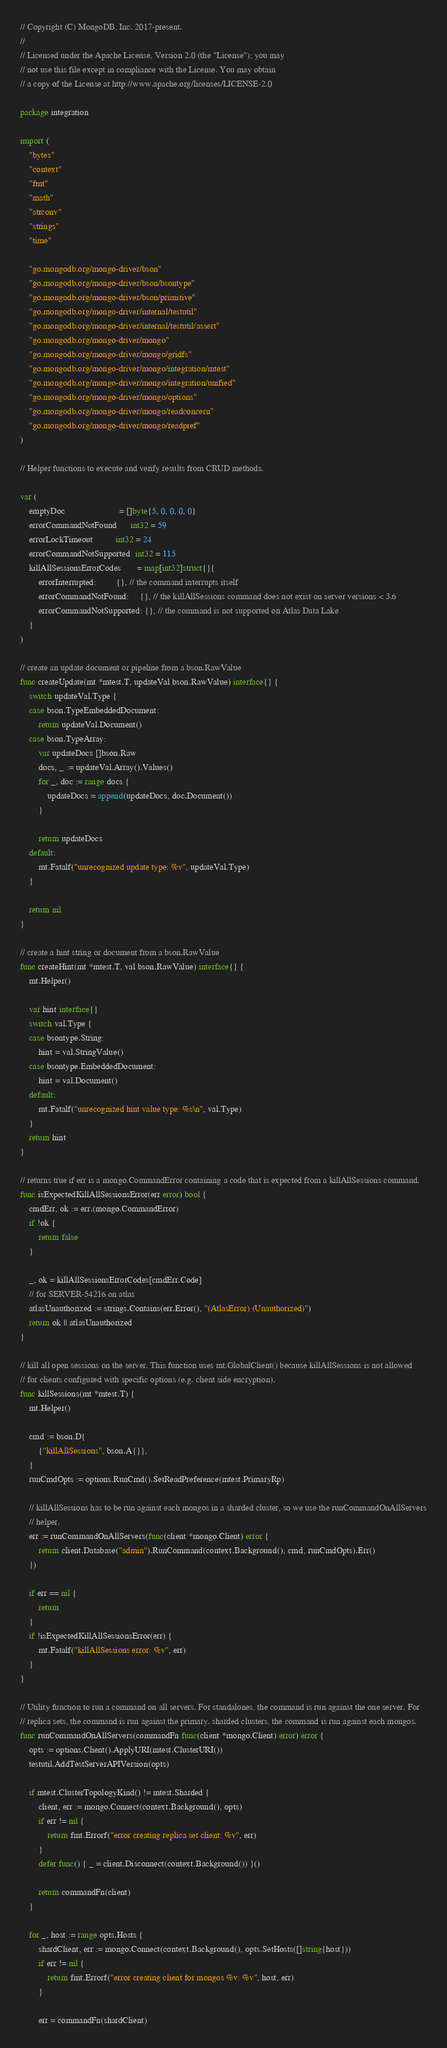<code> <loc_0><loc_0><loc_500><loc_500><_Go_>// Copyright (C) MongoDB, Inc. 2017-present.
//
// Licensed under the Apache License, Version 2.0 (the "License"); you may
// not use this file except in compliance with the License. You may obtain
// a copy of the License at http://www.apache.org/licenses/LICENSE-2.0

package integration

import (
	"bytes"
	"context"
	"fmt"
	"math"
	"strconv"
	"strings"
	"time"

	"go.mongodb.org/mongo-driver/bson"
	"go.mongodb.org/mongo-driver/bson/bsontype"
	"go.mongodb.org/mongo-driver/bson/primitive"
	"go.mongodb.org/mongo-driver/internal/testutil"
	"go.mongodb.org/mongo-driver/internal/testutil/assert"
	"go.mongodb.org/mongo-driver/mongo"
	"go.mongodb.org/mongo-driver/mongo/gridfs"
	"go.mongodb.org/mongo-driver/mongo/integration/mtest"
	"go.mongodb.org/mongo-driver/mongo/integration/unified"
	"go.mongodb.org/mongo-driver/mongo/options"
	"go.mongodb.org/mongo-driver/mongo/readconcern"
	"go.mongodb.org/mongo-driver/mongo/readpref"
)

// Helper functions to execute and verify results from CRUD methods.

var (
	emptyDoc                        = []byte{5, 0, 0, 0, 0}
	errorCommandNotFound      int32 = 59
	errorLockTimeout          int32 = 24
	errorCommandNotSupported  int32 = 115
	killAllSessionsErrorCodes       = map[int32]struct{}{
		errorInterrupted:         {}, // the command interrupts itself
		errorCommandNotFound:     {}, // the killAllSessions command does not exist on server versions < 3.6
		errorCommandNotSupported: {}, // the command is not supported on Atlas Data Lake
	}
)

// create an update document or pipeline from a bson.RawValue
func createUpdate(mt *mtest.T, updateVal bson.RawValue) interface{} {
	switch updateVal.Type {
	case bson.TypeEmbeddedDocument:
		return updateVal.Document()
	case bson.TypeArray:
		var updateDocs []bson.Raw
		docs, _ := updateVal.Array().Values()
		for _, doc := range docs {
			updateDocs = append(updateDocs, doc.Document())
		}

		return updateDocs
	default:
		mt.Fatalf("unrecognized update type: %v", updateVal.Type)
	}

	return nil
}

// create a hint string or document from a bson.RawValue
func createHint(mt *mtest.T, val bson.RawValue) interface{} {
	mt.Helper()

	var hint interface{}
	switch val.Type {
	case bsontype.String:
		hint = val.StringValue()
	case bsontype.EmbeddedDocument:
		hint = val.Document()
	default:
		mt.Fatalf("unrecognized hint value type: %s\n", val.Type)
	}
	return hint
}

// returns true if err is a mongo.CommandError containing a code that is expected from a killAllSessions command.
func isExpectedKillAllSessionsError(err error) bool {
	cmdErr, ok := err.(mongo.CommandError)
	if !ok {
		return false
	}

	_, ok = killAllSessionsErrorCodes[cmdErr.Code]
	// for SERVER-54216 on atlas
	atlasUnauthorized := strings.Contains(err.Error(), "(AtlasError) (Unauthorized)")
	return ok || atlasUnauthorized
}

// kill all open sessions on the server. This function uses mt.GlobalClient() because killAllSessions is not allowed
// for clients configured with specific options (e.g. client side encryption).
func killSessions(mt *mtest.T) {
	mt.Helper()

	cmd := bson.D{
		{"killAllSessions", bson.A{}},
	}
	runCmdOpts := options.RunCmd().SetReadPreference(mtest.PrimaryRp)

	// killAllSessions has to be run against each mongos in a sharded cluster, so we use the runCommandOnAllServers
	// helper.
	err := runCommandOnAllServers(func(client *mongo.Client) error {
		return client.Database("admin").RunCommand(context.Background(), cmd, runCmdOpts).Err()
	})

	if err == nil {
		return
	}
	if !isExpectedKillAllSessionsError(err) {
		mt.Fatalf("killAllSessions error: %v", err)
	}
}

// Utility function to run a command on all servers. For standalones, the command is run against the one server. For
// replica sets, the command is run against the primary. sharded clusters, the command is run against each mongos.
func runCommandOnAllServers(commandFn func(client *mongo.Client) error) error {
	opts := options.Client().ApplyURI(mtest.ClusterURI())
	testutil.AddTestServerAPIVersion(opts)

	if mtest.ClusterTopologyKind() != mtest.Sharded {
		client, err := mongo.Connect(context.Background(), opts)
		if err != nil {
			return fmt.Errorf("error creating replica set client: %v", err)
		}
		defer func() { _ = client.Disconnect(context.Background()) }()

		return commandFn(client)
	}

	for _, host := range opts.Hosts {
		shardClient, err := mongo.Connect(context.Background(), opts.SetHosts([]string{host}))
		if err != nil {
			return fmt.Errorf("error creating client for mongos %v: %v", host, err)
		}

		err = commandFn(shardClient)</code> 